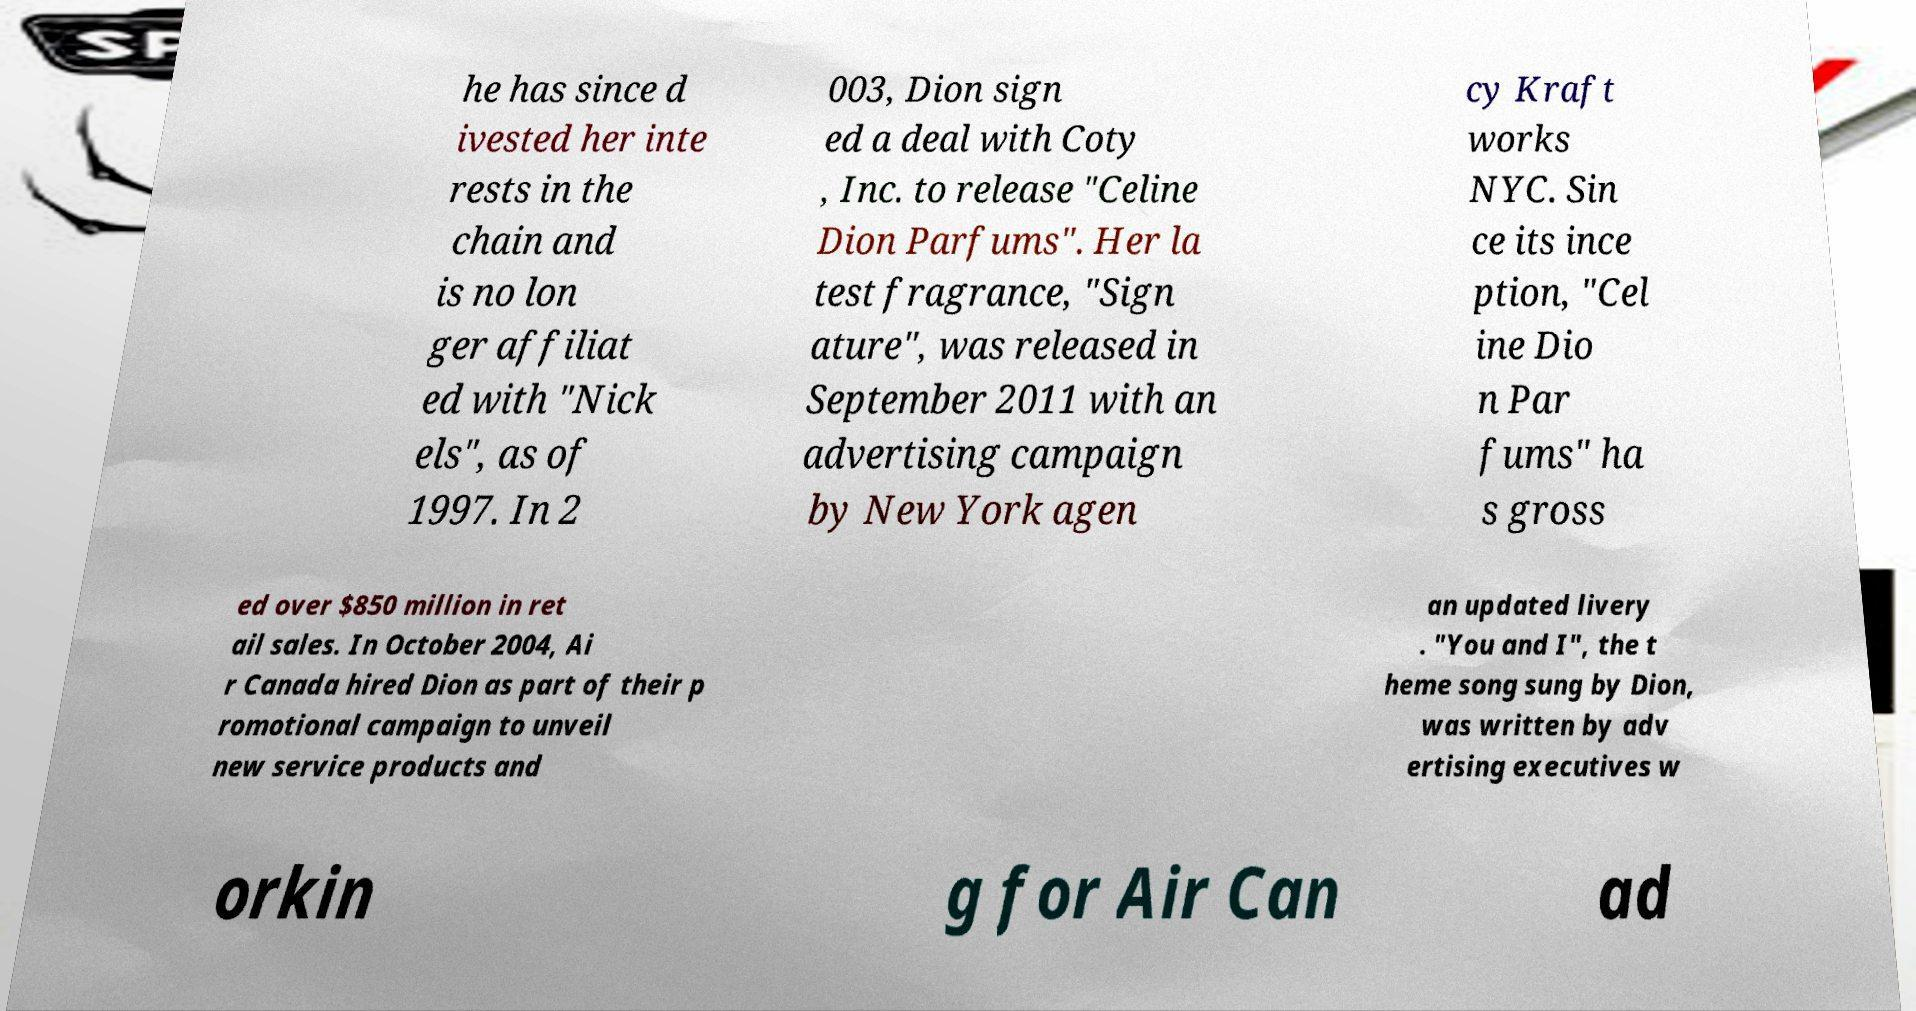I need the written content from this picture converted into text. Can you do that? he has since d ivested her inte rests in the chain and is no lon ger affiliat ed with "Nick els", as of 1997. In 2 003, Dion sign ed a deal with Coty , Inc. to release "Celine Dion Parfums". Her la test fragrance, "Sign ature", was released in September 2011 with an advertising campaign by New York agen cy Kraft works NYC. Sin ce its ince ption, "Cel ine Dio n Par fums" ha s gross ed over $850 million in ret ail sales. In October 2004, Ai r Canada hired Dion as part of their p romotional campaign to unveil new service products and an updated livery . "You and I", the t heme song sung by Dion, was written by adv ertising executives w orkin g for Air Can ad 